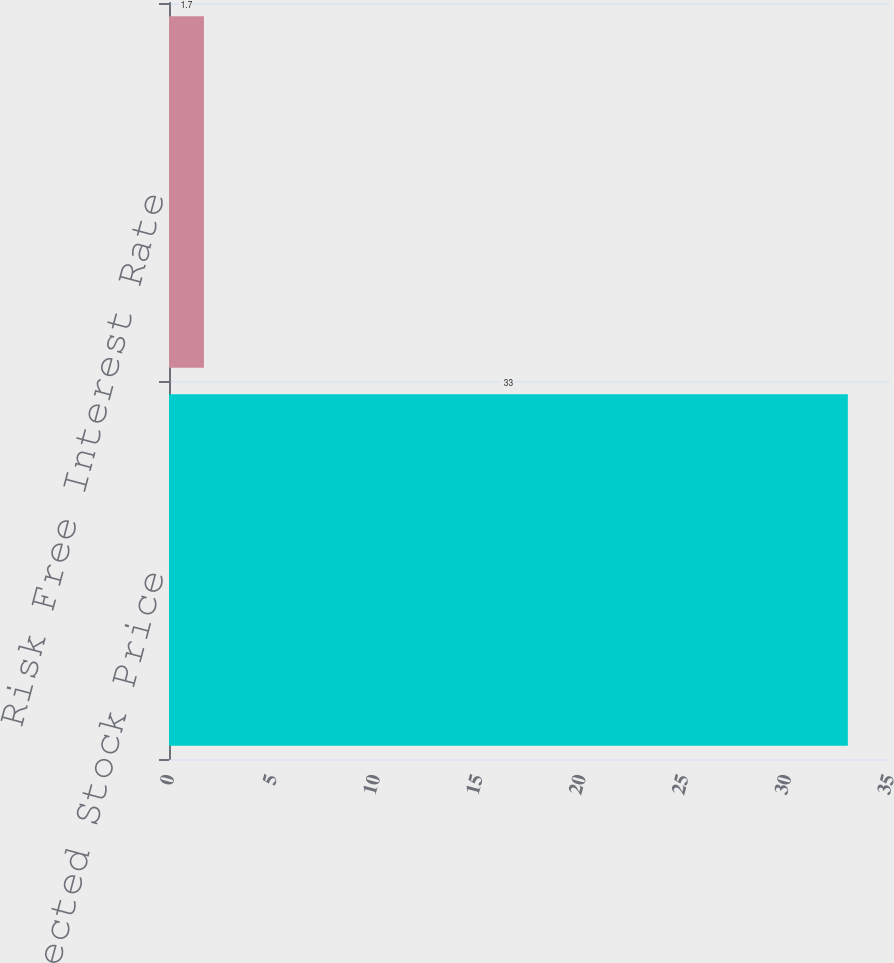Convert chart. <chart><loc_0><loc_0><loc_500><loc_500><bar_chart><fcel>Expected Stock Price<fcel>Risk Free Interest Rate<nl><fcel>33<fcel>1.7<nl></chart> 